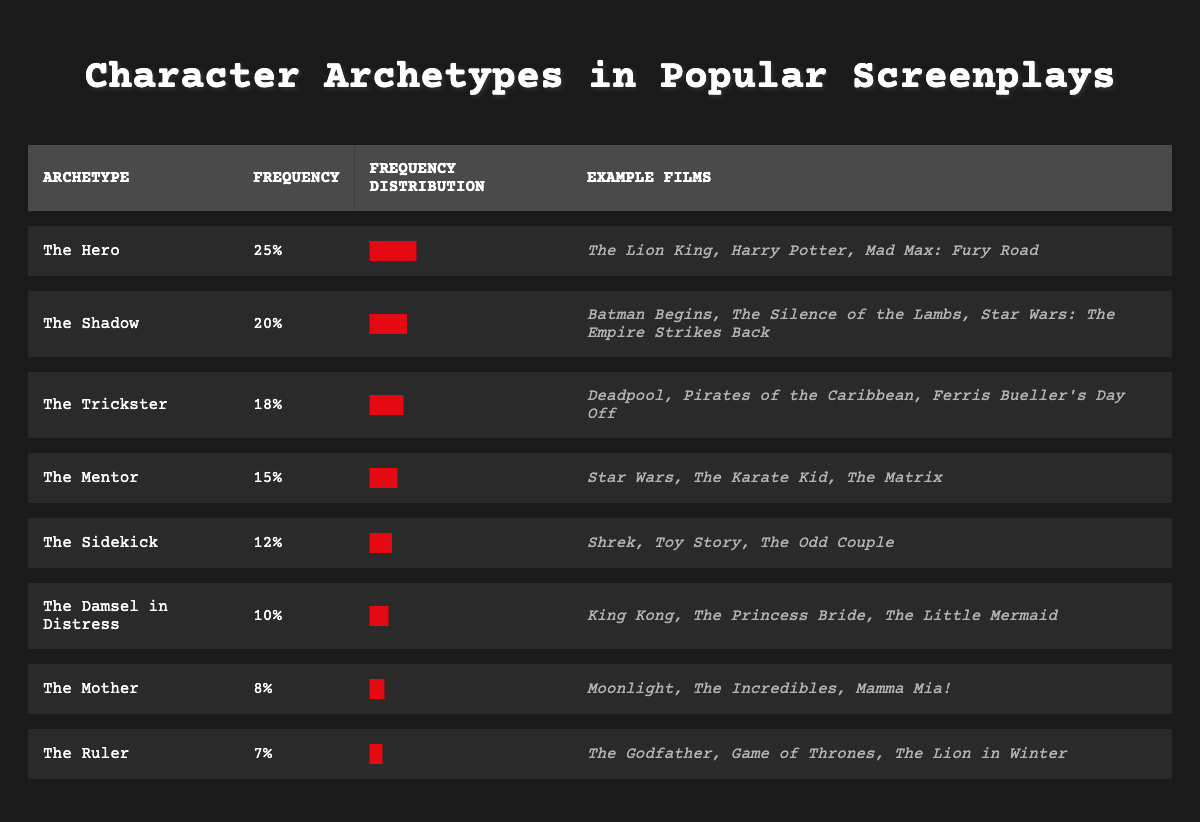What character archetype has the highest frequency? Referring to the table, "The Hero" archetype has a frequency of 25, which is the highest among all listed archetypes.
Answer: The Hero Which archetype appears less frequently: The Mother or The Sidekick? The frequency of "The Mother" is 8, while "The Sidekick" has a frequency of 12. Since 8 is less than 12, "The Mother" appears less frequently than "The Sidekick."
Answer: The Mother How many archetypes have a frequency of 15 or higher? The archetypes with a frequency of 15 or higher are: The Hero (25), The Shadow (20), The Trickster (18), and The Mentor (15). That totals to 4 archetypes.
Answer: 4 True or False: The Damsel in Distress is the least common archetype. The Damsel in Distress has a frequency of 10. The Mother (8) has a lower frequency than The Damsel in Distress, so the statement is false.
Answer: False What is the combined frequency of The Ruler and The Mother? The Ruler has a frequency of 7, and The Mother has a frequency of 8. Adding these together gives 7 + 8 = 15 for the combined frequency.
Answer: 15 Which two archetypes have the closest frequencies? The Shadow (20) and The Trickster (18) have frequencies of 20 and 18 respectively, which are only 2 units apart. Therefore, they have the closest frequencies.
Answer: The Shadow and The Trickster What percentage of the total frequency does The Mentor represent? Total frequency is 25 + 15 + 20 + 18 + 10 + 12 + 8 + 7 = 115. The Mentor frequency is 15. To find the percentage: (15/115) * 100 ≈ 13.04%.
Answer: Approximately 13.04% How many archetypes have a frequency greater than 15? The archetypes with a frequency greater than 15 are: The Hero (25), The Shadow (20), and The Trickster (18). This gives a total of 3 archetypes.
Answer: 3 